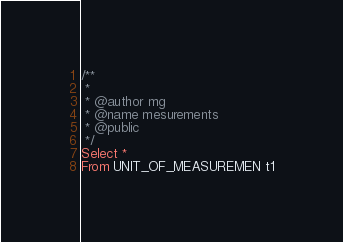Convert code to text. <code><loc_0><loc_0><loc_500><loc_500><_SQL_>/**
 *
 * @author mg 
 * @name mesurements
 * @public
 */ 
Select * 
From UNIT_OF_MEASUREMEN t1</code> 